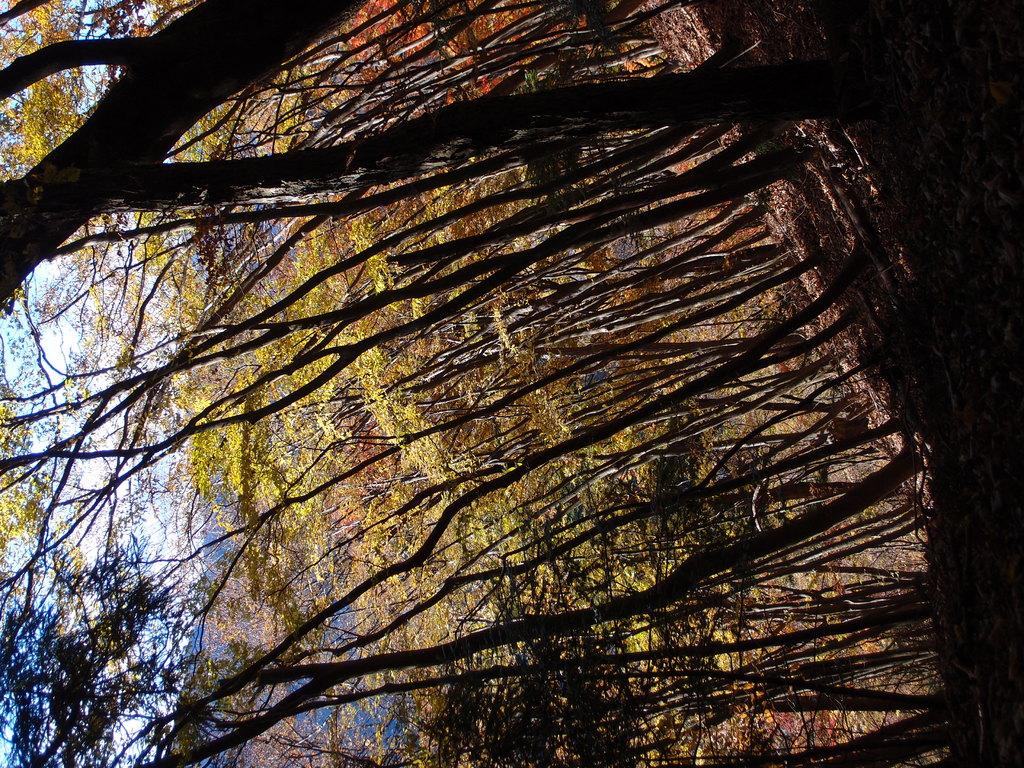What type of vegetation can be seen in the image? There are trees in the image. How would you describe the sky in the image? The sky is blue and cloudy in the image. What part of the library is shown in the image? There is no library present in the image. How does the image depict the act of saying good-bye? The image does not depict the act of saying good-bye. 